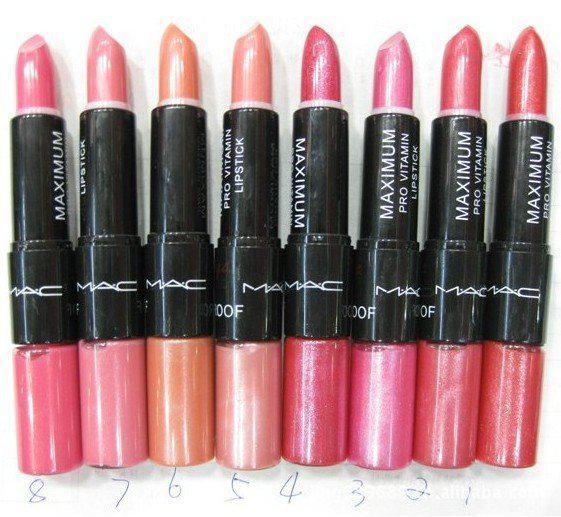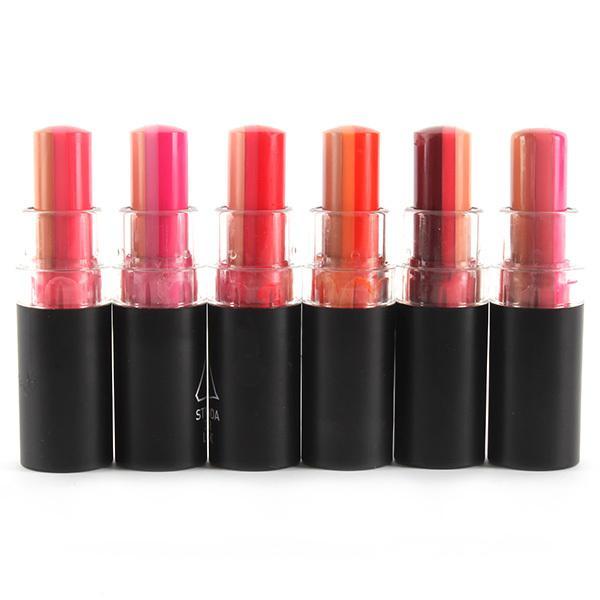The first image is the image on the left, the second image is the image on the right. Examine the images to the left and right. Is the description "The image to the left contains exactly 6 lipsticks." accurate? Answer yes or no. No. 